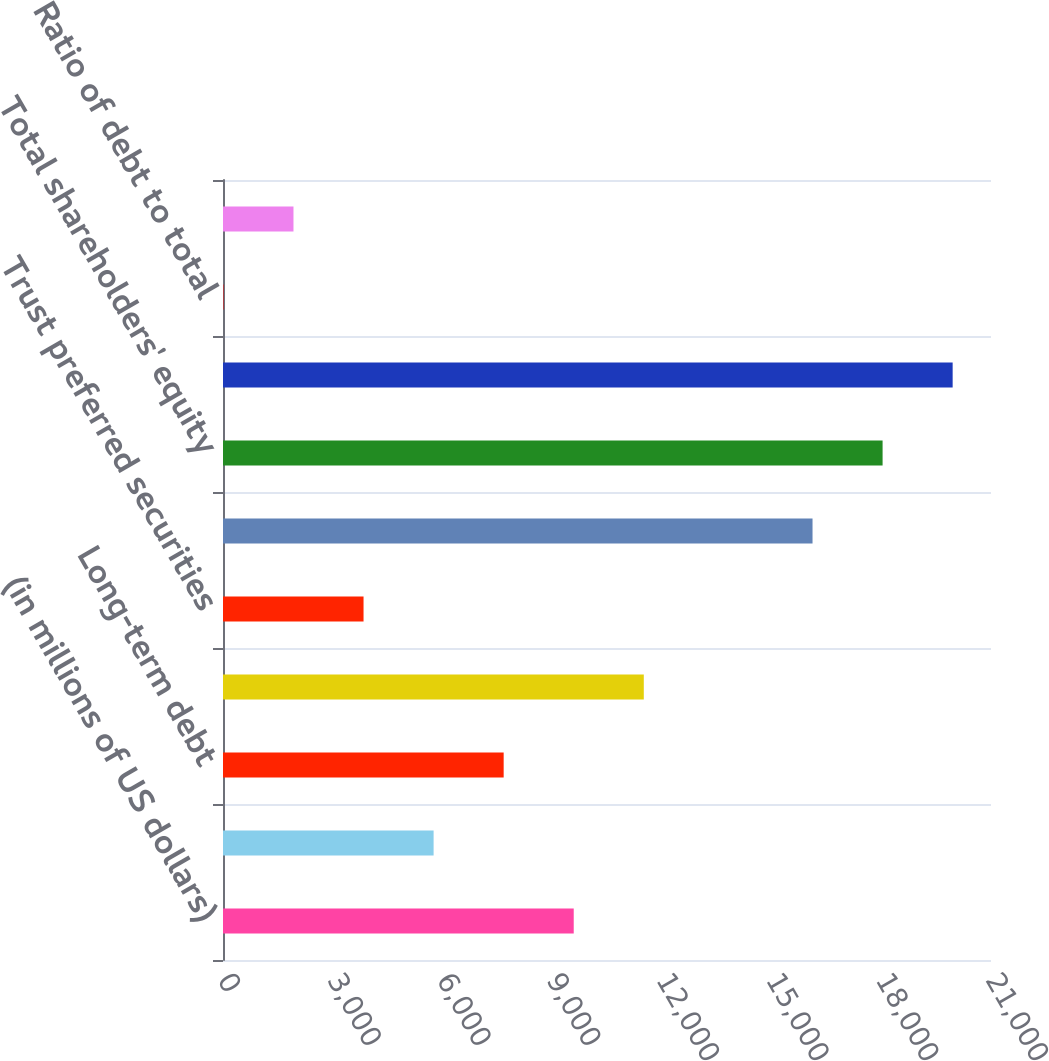Convert chart. <chart><loc_0><loc_0><loc_500><loc_500><bar_chart><fcel>(in millions of US dollars)<fcel>Short-term debt<fcel>Long-term debt<fcel>Total debt<fcel>Trust preferred securities<fcel>Common shareholders' equity<fcel>Total shareholders' equity<fcel>Total capitalization<fcel>Ratio of debt to total<fcel>Ratio of debt plus trust<nl><fcel>9590.2<fcel>5758.68<fcel>7674.44<fcel>11506<fcel>3842.92<fcel>16120<fcel>18035.8<fcel>19951.5<fcel>11.4<fcel>1927.16<nl></chart> 